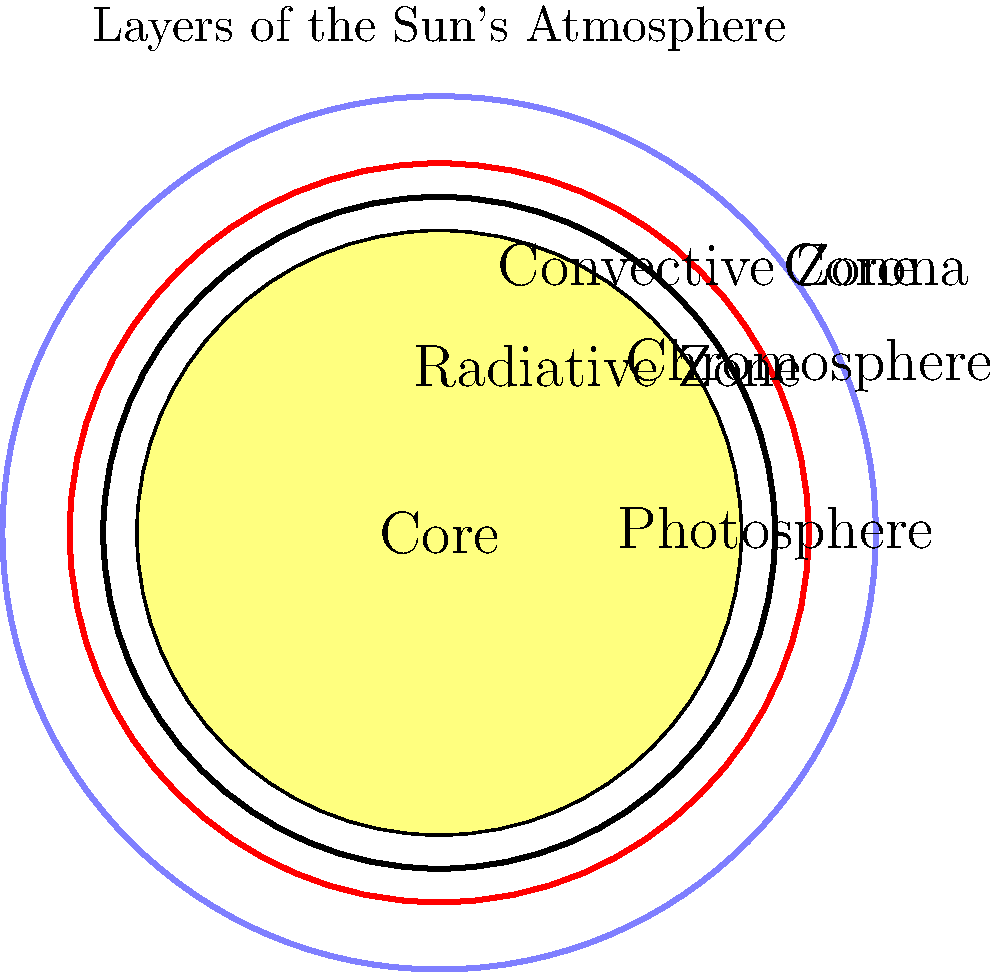As an architect exploring innovative building materials, you're intrigued by the Sun's structure and its potential inspiration for sustainable design. In the cross-sectional diagram of the Sun's atmosphere, which layer is responsible for the visible surface we observe from Earth, and how might its properties inform the development of energy-efficient building envelopes? To answer this question, let's examine the layers of the Sun's atmosphere step-by-step:

1. Core: The innermost layer where nuclear fusion occurs.
2. Radiative Zone: Energy is transferred outward through radiation.
3. Convective Zone: Energy moves through convection currents.
4. Photosphere: This is the visible "surface" of the Sun.
5. Chromosphere: A thin layer above the photosphere.
6. Corona: The outermost layer of the Sun's atmosphere.

The layer responsible for the visible surface we observe from Earth is the photosphere. It's important for architects to understand this layer because:

1. The photosphere is the primary source of solar radiation reaching Earth.
2. It has a temperature of about 5,800 K (5,527°C or 9,980°F).
3. It emits light across the visible spectrum, which is crucial for daylighting in buildings.

Properties of the photosphere that could inform energy-efficient building envelopes:

1. Opacity: The photosphere is opaque, suggesting the importance of selective transparency in building materials.
2. Temperature gradient: There's a sharp temperature drop in this layer, reminiscent of the thermal barriers needed in building envelopes.
3. Energy transfer: The photosphere marks the transition from convective to radiative energy transfer, which could inspire hybrid heating/cooling systems in buildings.

An architect could use this knowledge to develop building envelopes that:
- Selectively filter different wavelengths of light for optimal internal lighting and heat management.
- Incorporate materials with varying opacity to control solar gain.
- Design layered facades that mimic the Sun's energy transfer mechanisms for improved thermal regulation.
Answer: Photosphere; inspires selective transparency, thermal barriers, and hybrid energy transfer systems in building envelopes. 